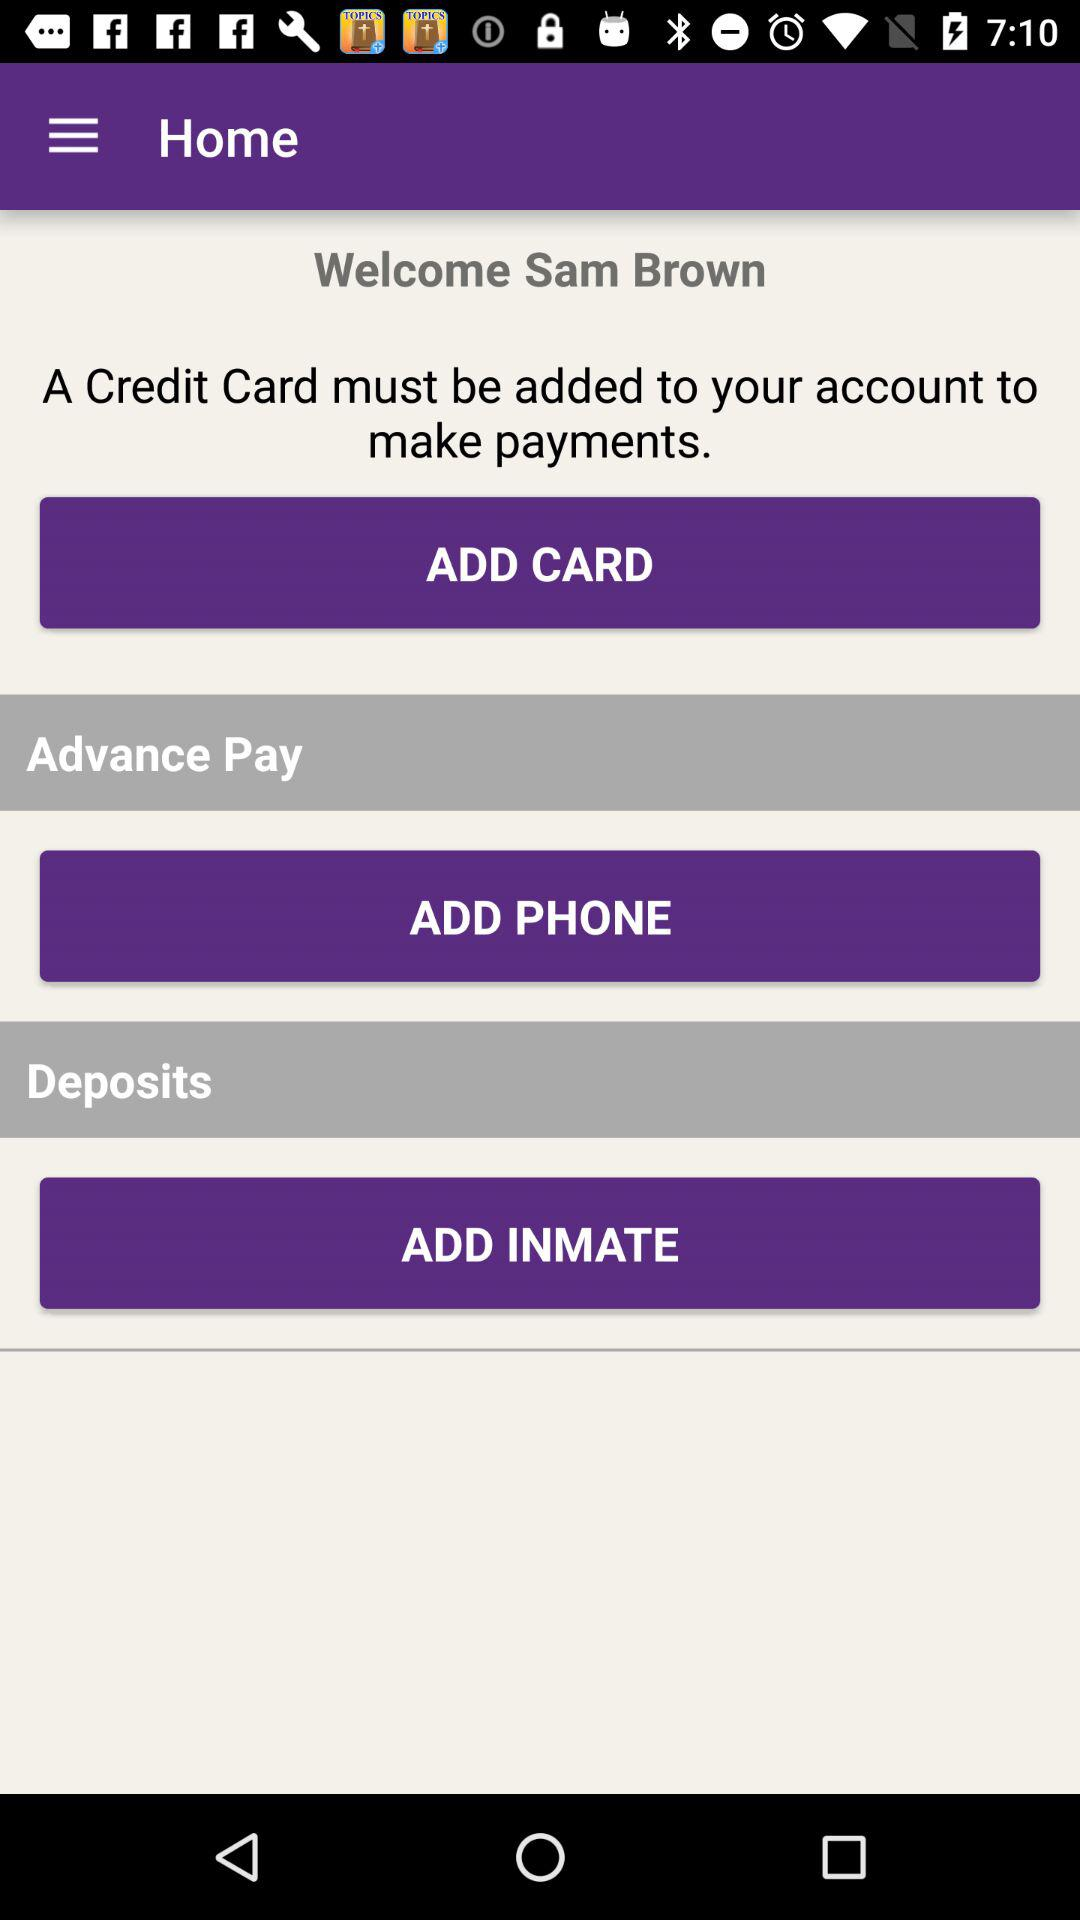How much is deposited?
When the provided information is insufficient, respond with <no answer>. <no answer> 